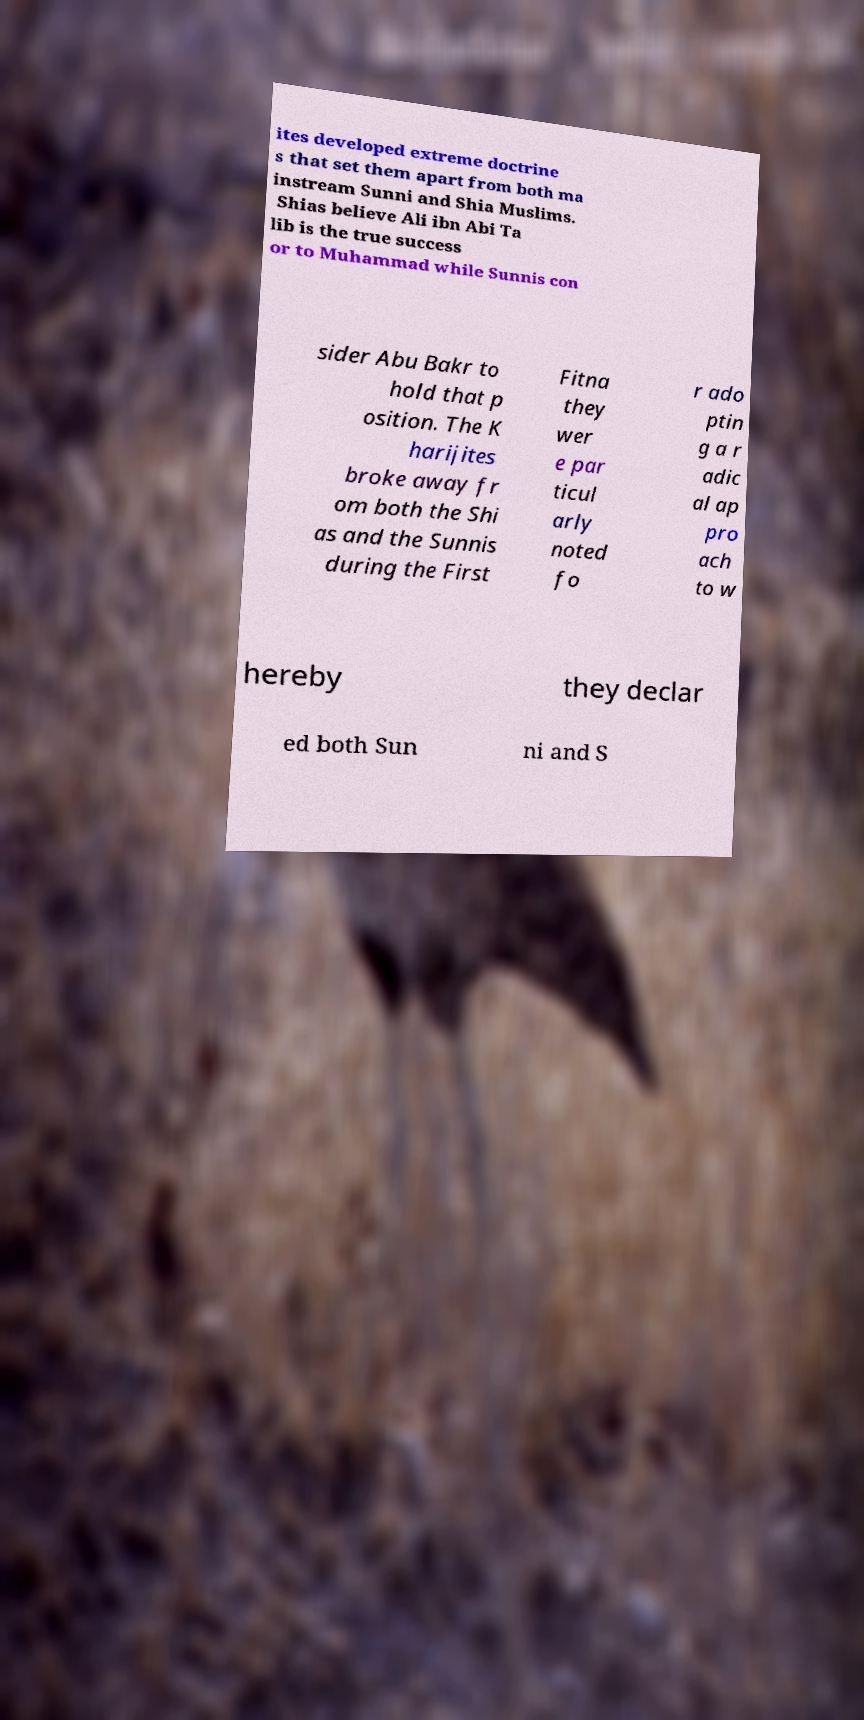Could you extract and type out the text from this image? ites developed extreme doctrine s that set them apart from both ma instream Sunni and Shia Muslims. Shias believe Ali ibn Abi Ta lib is the true success or to Muhammad while Sunnis con sider Abu Bakr to hold that p osition. The K harijites broke away fr om both the Shi as and the Sunnis during the First Fitna they wer e par ticul arly noted fo r ado ptin g a r adic al ap pro ach to w hereby they declar ed both Sun ni and S 